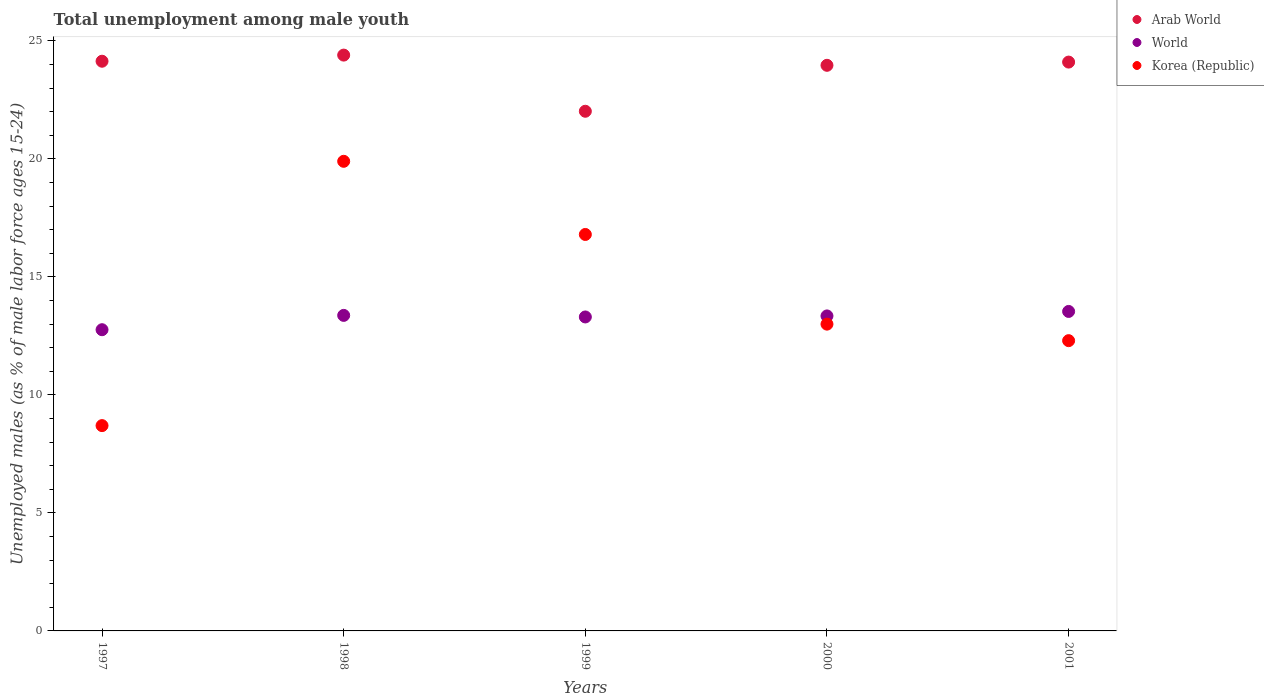How many different coloured dotlines are there?
Provide a succinct answer. 3. Is the number of dotlines equal to the number of legend labels?
Offer a terse response. Yes. What is the percentage of unemployed males in in Arab World in 1999?
Give a very brief answer. 22.02. Across all years, what is the maximum percentage of unemployed males in in Korea (Republic)?
Give a very brief answer. 19.9. Across all years, what is the minimum percentage of unemployed males in in World?
Keep it short and to the point. 12.76. What is the total percentage of unemployed males in in Arab World in the graph?
Offer a terse response. 118.64. What is the difference between the percentage of unemployed males in in World in 1997 and that in 2001?
Offer a very short reply. -0.77. What is the difference between the percentage of unemployed males in in Arab World in 2001 and the percentage of unemployed males in in World in 2000?
Offer a terse response. 10.76. What is the average percentage of unemployed males in in Korea (Republic) per year?
Your answer should be very brief. 14.14. In the year 1999, what is the difference between the percentage of unemployed males in in Korea (Republic) and percentage of unemployed males in in World?
Ensure brevity in your answer.  3.5. What is the ratio of the percentage of unemployed males in in World in 1999 to that in 2001?
Your answer should be very brief. 0.98. What is the difference between the highest and the second highest percentage of unemployed males in in Korea (Republic)?
Your response must be concise. 3.1. What is the difference between the highest and the lowest percentage of unemployed males in in World?
Provide a short and direct response. 0.77. In how many years, is the percentage of unemployed males in in World greater than the average percentage of unemployed males in in World taken over all years?
Offer a terse response. 4. Is it the case that in every year, the sum of the percentage of unemployed males in in Korea (Republic) and percentage of unemployed males in in World  is greater than the percentage of unemployed males in in Arab World?
Give a very brief answer. No. Does the percentage of unemployed males in in Korea (Republic) monotonically increase over the years?
Provide a succinct answer. No. Is the percentage of unemployed males in in World strictly greater than the percentage of unemployed males in in Korea (Republic) over the years?
Your answer should be compact. No. How many dotlines are there?
Provide a succinct answer. 3. What is the difference between two consecutive major ticks on the Y-axis?
Provide a short and direct response. 5. Does the graph contain grids?
Your answer should be very brief. No. How many legend labels are there?
Provide a short and direct response. 3. What is the title of the graph?
Provide a succinct answer. Total unemployment among male youth. Does "Gabon" appear as one of the legend labels in the graph?
Provide a succinct answer. No. What is the label or title of the X-axis?
Make the answer very short. Years. What is the label or title of the Y-axis?
Offer a very short reply. Unemployed males (as % of male labor force ages 15-24). What is the Unemployed males (as % of male labor force ages 15-24) of Arab World in 1997?
Your answer should be very brief. 24.14. What is the Unemployed males (as % of male labor force ages 15-24) in World in 1997?
Give a very brief answer. 12.76. What is the Unemployed males (as % of male labor force ages 15-24) in Korea (Republic) in 1997?
Make the answer very short. 8.7. What is the Unemployed males (as % of male labor force ages 15-24) of Arab World in 1998?
Your answer should be very brief. 24.4. What is the Unemployed males (as % of male labor force ages 15-24) of World in 1998?
Provide a succinct answer. 13.37. What is the Unemployed males (as % of male labor force ages 15-24) of Korea (Republic) in 1998?
Ensure brevity in your answer.  19.9. What is the Unemployed males (as % of male labor force ages 15-24) of Arab World in 1999?
Give a very brief answer. 22.02. What is the Unemployed males (as % of male labor force ages 15-24) in World in 1999?
Offer a very short reply. 13.3. What is the Unemployed males (as % of male labor force ages 15-24) in Korea (Republic) in 1999?
Offer a very short reply. 16.8. What is the Unemployed males (as % of male labor force ages 15-24) in Arab World in 2000?
Provide a short and direct response. 23.97. What is the Unemployed males (as % of male labor force ages 15-24) of World in 2000?
Provide a short and direct response. 13.35. What is the Unemployed males (as % of male labor force ages 15-24) in Arab World in 2001?
Your answer should be very brief. 24.1. What is the Unemployed males (as % of male labor force ages 15-24) in World in 2001?
Ensure brevity in your answer.  13.54. What is the Unemployed males (as % of male labor force ages 15-24) in Korea (Republic) in 2001?
Offer a terse response. 12.3. Across all years, what is the maximum Unemployed males (as % of male labor force ages 15-24) of Arab World?
Give a very brief answer. 24.4. Across all years, what is the maximum Unemployed males (as % of male labor force ages 15-24) in World?
Offer a terse response. 13.54. Across all years, what is the maximum Unemployed males (as % of male labor force ages 15-24) in Korea (Republic)?
Your response must be concise. 19.9. Across all years, what is the minimum Unemployed males (as % of male labor force ages 15-24) of Arab World?
Your response must be concise. 22.02. Across all years, what is the minimum Unemployed males (as % of male labor force ages 15-24) of World?
Keep it short and to the point. 12.76. Across all years, what is the minimum Unemployed males (as % of male labor force ages 15-24) of Korea (Republic)?
Your answer should be compact. 8.7. What is the total Unemployed males (as % of male labor force ages 15-24) in Arab World in the graph?
Give a very brief answer. 118.64. What is the total Unemployed males (as % of male labor force ages 15-24) of World in the graph?
Your response must be concise. 66.32. What is the total Unemployed males (as % of male labor force ages 15-24) in Korea (Republic) in the graph?
Provide a short and direct response. 70.7. What is the difference between the Unemployed males (as % of male labor force ages 15-24) of Arab World in 1997 and that in 1998?
Provide a succinct answer. -0.26. What is the difference between the Unemployed males (as % of male labor force ages 15-24) of World in 1997 and that in 1998?
Your response must be concise. -0.61. What is the difference between the Unemployed males (as % of male labor force ages 15-24) in Arab World in 1997 and that in 1999?
Make the answer very short. 2.12. What is the difference between the Unemployed males (as % of male labor force ages 15-24) in World in 1997 and that in 1999?
Your answer should be compact. -0.54. What is the difference between the Unemployed males (as % of male labor force ages 15-24) in Korea (Republic) in 1997 and that in 1999?
Your answer should be compact. -8.1. What is the difference between the Unemployed males (as % of male labor force ages 15-24) in Arab World in 1997 and that in 2000?
Your answer should be compact. 0.17. What is the difference between the Unemployed males (as % of male labor force ages 15-24) of World in 1997 and that in 2000?
Ensure brevity in your answer.  -0.58. What is the difference between the Unemployed males (as % of male labor force ages 15-24) in Korea (Republic) in 1997 and that in 2000?
Give a very brief answer. -4.3. What is the difference between the Unemployed males (as % of male labor force ages 15-24) of Arab World in 1997 and that in 2001?
Give a very brief answer. 0.04. What is the difference between the Unemployed males (as % of male labor force ages 15-24) in World in 1997 and that in 2001?
Your answer should be compact. -0.77. What is the difference between the Unemployed males (as % of male labor force ages 15-24) in Korea (Republic) in 1997 and that in 2001?
Give a very brief answer. -3.6. What is the difference between the Unemployed males (as % of male labor force ages 15-24) of Arab World in 1998 and that in 1999?
Provide a short and direct response. 2.38. What is the difference between the Unemployed males (as % of male labor force ages 15-24) in World in 1998 and that in 1999?
Your answer should be very brief. 0.07. What is the difference between the Unemployed males (as % of male labor force ages 15-24) in Korea (Republic) in 1998 and that in 1999?
Offer a terse response. 3.1. What is the difference between the Unemployed males (as % of male labor force ages 15-24) of Arab World in 1998 and that in 2000?
Keep it short and to the point. 0.43. What is the difference between the Unemployed males (as % of male labor force ages 15-24) of World in 1998 and that in 2000?
Give a very brief answer. 0.02. What is the difference between the Unemployed males (as % of male labor force ages 15-24) of Korea (Republic) in 1998 and that in 2000?
Provide a short and direct response. 6.9. What is the difference between the Unemployed males (as % of male labor force ages 15-24) in Arab World in 1998 and that in 2001?
Ensure brevity in your answer.  0.3. What is the difference between the Unemployed males (as % of male labor force ages 15-24) in World in 1998 and that in 2001?
Make the answer very short. -0.17. What is the difference between the Unemployed males (as % of male labor force ages 15-24) in Korea (Republic) in 1998 and that in 2001?
Offer a very short reply. 7.6. What is the difference between the Unemployed males (as % of male labor force ages 15-24) of Arab World in 1999 and that in 2000?
Your response must be concise. -1.95. What is the difference between the Unemployed males (as % of male labor force ages 15-24) in World in 1999 and that in 2000?
Make the answer very short. -0.04. What is the difference between the Unemployed males (as % of male labor force ages 15-24) of Arab World in 1999 and that in 2001?
Give a very brief answer. -2.08. What is the difference between the Unemployed males (as % of male labor force ages 15-24) of World in 1999 and that in 2001?
Keep it short and to the point. -0.23. What is the difference between the Unemployed males (as % of male labor force ages 15-24) of Korea (Republic) in 1999 and that in 2001?
Keep it short and to the point. 4.5. What is the difference between the Unemployed males (as % of male labor force ages 15-24) in Arab World in 2000 and that in 2001?
Give a very brief answer. -0.14. What is the difference between the Unemployed males (as % of male labor force ages 15-24) in World in 2000 and that in 2001?
Your answer should be very brief. -0.19. What is the difference between the Unemployed males (as % of male labor force ages 15-24) of Arab World in 1997 and the Unemployed males (as % of male labor force ages 15-24) of World in 1998?
Give a very brief answer. 10.77. What is the difference between the Unemployed males (as % of male labor force ages 15-24) of Arab World in 1997 and the Unemployed males (as % of male labor force ages 15-24) of Korea (Republic) in 1998?
Give a very brief answer. 4.24. What is the difference between the Unemployed males (as % of male labor force ages 15-24) in World in 1997 and the Unemployed males (as % of male labor force ages 15-24) in Korea (Republic) in 1998?
Provide a succinct answer. -7.14. What is the difference between the Unemployed males (as % of male labor force ages 15-24) in Arab World in 1997 and the Unemployed males (as % of male labor force ages 15-24) in World in 1999?
Your answer should be very brief. 10.84. What is the difference between the Unemployed males (as % of male labor force ages 15-24) of Arab World in 1997 and the Unemployed males (as % of male labor force ages 15-24) of Korea (Republic) in 1999?
Your answer should be compact. 7.34. What is the difference between the Unemployed males (as % of male labor force ages 15-24) of World in 1997 and the Unemployed males (as % of male labor force ages 15-24) of Korea (Republic) in 1999?
Give a very brief answer. -4.04. What is the difference between the Unemployed males (as % of male labor force ages 15-24) of Arab World in 1997 and the Unemployed males (as % of male labor force ages 15-24) of World in 2000?
Make the answer very short. 10.79. What is the difference between the Unemployed males (as % of male labor force ages 15-24) in Arab World in 1997 and the Unemployed males (as % of male labor force ages 15-24) in Korea (Republic) in 2000?
Provide a short and direct response. 11.14. What is the difference between the Unemployed males (as % of male labor force ages 15-24) of World in 1997 and the Unemployed males (as % of male labor force ages 15-24) of Korea (Republic) in 2000?
Offer a very short reply. -0.24. What is the difference between the Unemployed males (as % of male labor force ages 15-24) in Arab World in 1997 and the Unemployed males (as % of male labor force ages 15-24) in World in 2001?
Offer a very short reply. 10.6. What is the difference between the Unemployed males (as % of male labor force ages 15-24) of Arab World in 1997 and the Unemployed males (as % of male labor force ages 15-24) of Korea (Republic) in 2001?
Your response must be concise. 11.84. What is the difference between the Unemployed males (as % of male labor force ages 15-24) in World in 1997 and the Unemployed males (as % of male labor force ages 15-24) in Korea (Republic) in 2001?
Provide a short and direct response. 0.46. What is the difference between the Unemployed males (as % of male labor force ages 15-24) in Arab World in 1998 and the Unemployed males (as % of male labor force ages 15-24) in World in 1999?
Provide a succinct answer. 11.1. What is the difference between the Unemployed males (as % of male labor force ages 15-24) of Arab World in 1998 and the Unemployed males (as % of male labor force ages 15-24) of Korea (Republic) in 1999?
Give a very brief answer. 7.6. What is the difference between the Unemployed males (as % of male labor force ages 15-24) of World in 1998 and the Unemployed males (as % of male labor force ages 15-24) of Korea (Republic) in 1999?
Make the answer very short. -3.43. What is the difference between the Unemployed males (as % of male labor force ages 15-24) in Arab World in 1998 and the Unemployed males (as % of male labor force ages 15-24) in World in 2000?
Make the answer very short. 11.05. What is the difference between the Unemployed males (as % of male labor force ages 15-24) of Arab World in 1998 and the Unemployed males (as % of male labor force ages 15-24) of Korea (Republic) in 2000?
Keep it short and to the point. 11.4. What is the difference between the Unemployed males (as % of male labor force ages 15-24) in World in 1998 and the Unemployed males (as % of male labor force ages 15-24) in Korea (Republic) in 2000?
Keep it short and to the point. 0.37. What is the difference between the Unemployed males (as % of male labor force ages 15-24) of Arab World in 1998 and the Unemployed males (as % of male labor force ages 15-24) of World in 2001?
Provide a short and direct response. 10.86. What is the difference between the Unemployed males (as % of male labor force ages 15-24) of Arab World in 1998 and the Unemployed males (as % of male labor force ages 15-24) of Korea (Republic) in 2001?
Your response must be concise. 12.1. What is the difference between the Unemployed males (as % of male labor force ages 15-24) in World in 1998 and the Unemployed males (as % of male labor force ages 15-24) in Korea (Republic) in 2001?
Make the answer very short. 1.07. What is the difference between the Unemployed males (as % of male labor force ages 15-24) in Arab World in 1999 and the Unemployed males (as % of male labor force ages 15-24) in World in 2000?
Provide a short and direct response. 8.67. What is the difference between the Unemployed males (as % of male labor force ages 15-24) in Arab World in 1999 and the Unemployed males (as % of male labor force ages 15-24) in Korea (Republic) in 2000?
Offer a terse response. 9.02. What is the difference between the Unemployed males (as % of male labor force ages 15-24) of World in 1999 and the Unemployed males (as % of male labor force ages 15-24) of Korea (Republic) in 2000?
Provide a short and direct response. 0.3. What is the difference between the Unemployed males (as % of male labor force ages 15-24) in Arab World in 1999 and the Unemployed males (as % of male labor force ages 15-24) in World in 2001?
Provide a short and direct response. 8.48. What is the difference between the Unemployed males (as % of male labor force ages 15-24) in Arab World in 1999 and the Unemployed males (as % of male labor force ages 15-24) in Korea (Republic) in 2001?
Keep it short and to the point. 9.72. What is the difference between the Unemployed males (as % of male labor force ages 15-24) of Arab World in 2000 and the Unemployed males (as % of male labor force ages 15-24) of World in 2001?
Give a very brief answer. 10.43. What is the difference between the Unemployed males (as % of male labor force ages 15-24) of Arab World in 2000 and the Unemployed males (as % of male labor force ages 15-24) of Korea (Republic) in 2001?
Your answer should be very brief. 11.67. What is the difference between the Unemployed males (as % of male labor force ages 15-24) of World in 2000 and the Unemployed males (as % of male labor force ages 15-24) of Korea (Republic) in 2001?
Provide a succinct answer. 1.05. What is the average Unemployed males (as % of male labor force ages 15-24) in Arab World per year?
Give a very brief answer. 23.73. What is the average Unemployed males (as % of male labor force ages 15-24) of World per year?
Give a very brief answer. 13.27. What is the average Unemployed males (as % of male labor force ages 15-24) of Korea (Republic) per year?
Make the answer very short. 14.14. In the year 1997, what is the difference between the Unemployed males (as % of male labor force ages 15-24) of Arab World and Unemployed males (as % of male labor force ages 15-24) of World?
Provide a short and direct response. 11.38. In the year 1997, what is the difference between the Unemployed males (as % of male labor force ages 15-24) in Arab World and Unemployed males (as % of male labor force ages 15-24) in Korea (Republic)?
Provide a succinct answer. 15.44. In the year 1997, what is the difference between the Unemployed males (as % of male labor force ages 15-24) of World and Unemployed males (as % of male labor force ages 15-24) of Korea (Republic)?
Provide a succinct answer. 4.06. In the year 1998, what is the difference between the Unemployed males (as % of male labor force ages 15-24) of Arab World and Unemployed males (as % of male labor force ages 15-24) of World?
Your response must be concise. 11.03. In the year 1998, what is the difference between the Unemployed males (as % of male labor force ages 15-24) of Arab World and Unemployed males (as % of male labor force ages 15-24) of Korea (Republic)?
Give a very brief answer. 4.5. In the year 1998, what is the difference between the Unemployed males (as % of male labor force ages 15-24) of World and Unemployed males (as % of male labor force ages 15-24) of Korea (Republic)?
Ensure brevity in your answer.  -6.53. In the year 1999, what is the difference between the Unemployed males (as % of male labor force ages 15-24) of Arab World and Unemployed males (as % of male labor force ages 15-24) of World?
Offer a terse response. 8.72. In the year 1999, what is the difference between the Unemployed males (as % of male labor force ages 15-24) in Arab World and Unemployed males (as % of male labor force ages 15-24) in Korea (Republic)?
Provide a succinct answer. 5.22. In the year 1999, what is the difference between the Unemployed males (as % of male labor force ages 15-24) of World and Unemployed males (as % of male labor force ages 15-24) of Korea (Republic)?
Make the answer very short. -3.5. In the year 2000, what is the difference between the Unemployed males (as % of male labor force ages 15-24) of Arab World and Unemployed males (as % of male labor force ages 15-24) of World?
Your response must be concise. 10.62. In the year 2000, what is the difference between the Unemployed males (as % of male labor force ages 15-24) in Arab World and Unemployed males (as % of male labor force ages 15-24) in Korea (Republic)?
Provide a short and direct response. 10.97. In the year 2000, what is the difference between the Unemployed males (as % of male labor force ages 15-24) of World and Unemployed males (as % of male labor force ages 15-24) of Korea (Republic)?
Give a very brief answer. 0.35. In the year 2001, what is the difference between the Unemployed males (as % of male labor force ages 15-24) in Arab World and Unemployed males (as % of male labor force ages 15-24) in World?
Offer a very short reply. 10.57. In the year 2001, what is the difference between the Unemployed males (as % of male labor force ages 15-24) of Arab World and Unemployed males (as % of male labor force ages 15-24) of Korea (Republic)?
Your response must be concise. 11.8. In the year 2001, what is the difference between the Unemployed males (as % of male labor force ages 15-24) in World and Unemployed males (as % of male labor force ages 15-24) in Korea (Republic)?
Offer a terse response. 1.24. What is the ratio of the Unemployed males (as % of male labor force ages 15-24) of World in 1997 to that in 1998?
Your answer should be very brief. 0.95. What is the ratio of the Unemployed males (as % of male labor force ages 15-24) of Korea (Republic) in 1997 to that in 1998?
Make the answer very short. 0.44. What is the ratio of the Unemployed males (as % of male labor force ages 15-24) in Arab World in 1997 to that in 1999?
Your answer should be very brief. 1.1. What is the ratio of the Unemployed males (as % of male labor force ages 15-24) in World in 1997 to that in 1999?
Provide a succinct answer. 0.96. What is the ratio of the Unemployed males (as % of male labor force ages 15-24) in Korea (Republic) in 1997 to that in 1999?
Your answer should be compact. 0.52. What is the ratio of the Unemployed males (as % of male labor force ages 15-24) in World in 1997 to that in 2000?
Offer a very short reply. 0.96. What is the ratio of the Unemployed males (as % of male labor force ages 15-24) of Korea (Republic) in 1997 to that in 2000?
Offer a terse response. 0.67. What is the ratio of the Unemployed males (as % of male labor force ages 15-24) of Arab World in 1997 to that in 2001?
Provide a succinct answer. 1. What is the ratio of the Unemployed males (as % of male labor force ages 15-24) of World in 1997 to that in 2001?
Provide a short and direct response. 0.94. What is the ratio of the Unemployed males (as % of male labor force ages 15-24) of Korea (Republic) in 1997 to that in 2001?
Offer a very short reply. 0.71. What is the ratio of the Unemployed males (as % of male labor force ages 15-24) in Arab World in 1998 to that in 1999?
Keep it short and to the point. 1.11. What is the ratio of the Unemployed males (as % of male labor force ages 15-24) of Korea (Republic) in 1998 to that in 1999?
Ensure brevity in your answer.  1.18. What is the ratio of the Unemployed males (as % of male labor force ages 15-24) in Arab World in 1998 to that in 2000?
Provide a short and direct response. 1.02. What is the ratio of the Unemployed males (as % of male labor force ages 15-24) of Korea (Republic) in 1998 to that in 2000?
Offer a terse response. 1.53. What is the ratio of the Unemployed males (as % of male labor force ages 15-24) in Arab World in 1998 to that in 2001?
Offer a terse response. 1.01. What is the ratio of the Unemployed males (as % of male labor force ages 15-24) in World in 1998 to that in 2001?
Give a very brief answer. 0.99. What is the ratio of the Unemployed males (as % of male labor force ages 15-24) of Korea (Republic) in 1998 to that in 2001?
Your answer should be very brief. 1.62. What is the ratio of the Unemployed males (as % of male labor force ages 15-24) of Arab World in 1999 to that in 2000?
Your answer should be compact. 0.92. What is the ratio of the Unemployed males (as % of male labor force ages 15-24) of World in 1999 to that in 2000?
Offer a terse response. 1. What is the ratio of the Unemployed males (as % of male labor force ages 15-24) of Korea (Republic) in 1999 to that in 2000?
Make the answer very short. 1.29. What is the ratio of the Unemployed males (as % of male labor force ages 15-24) of Arab World in 1999 to that in 2001?
Offer a terse response. 0.91. What is the ratio of the Unemployed males (as % of male labor force ages 15-24) in World in 1999 to that in 2001?
Keep it short and to the point. 0.98. What is the ratio of the Unemployed males (as % of male labor force ages 15-24) in Korea (Republic) in 1999 to that in 2001?
Your response must be concise. 1.37. What is the ratio of the Unemployed males (as % of male labor force ages 15-24) in World in 2000 to that in 2001?
Your answer should be compact. 0.99. What is the ratio of the Unemployed males (as % of male labor force ages 15-24) in Korea (Republic) in 2000 to that in 2001?
Your answer should be compact. 1.06. What is the difference between the highest and the second highest Unemployed males (as % of male labor force ages 15-24) in Arab World?
Offer a terse response. 0.26. What is the difference between the highest and the second highest Unemployed males (as % of male labor force ages 15-24) of World?
Your answer should be compact. 0.17. What is the difference between the highest and the second highest Unemployed males (as % of male labor force ages 15-24) in Korea (Republic)?
Provide a short and direct response. 3.1. What is the difference between the highest and the lowest Unemployed males (as % of male labor force ages 15-24) of Arab World?
Your response must be concise. 2.38. What is the difference between the highest and the lowest Unemployed males (as % of male labor force ages 15-24) of World?
Offer a terse response. 0.77. 